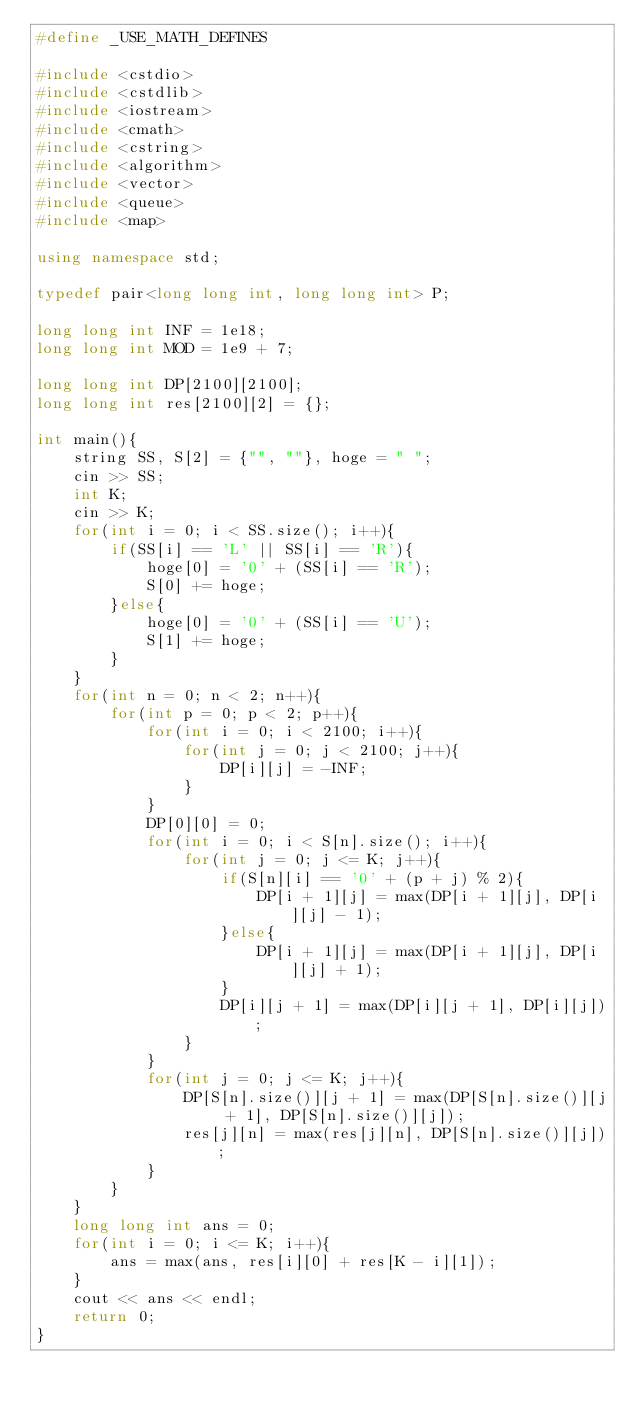Convert code to text. <code><loc_0><loc_0><loc_500><loc_500><_C++_>#define _USE_MATH_DEFINES

#include <cstdio>
#include <cstdlib>
#include <iostream>
#include <cmath>
#include <cstring>
#include <algorithm>
#include <vector>
#include <queue>
#include <map>

using namespace std;

typedef pair<long long int, long long int> P;

long long int INF = 1e18;
long long int MOD = 1e9 + 7;

long long int DP[2100][2100];
long long int res[2100][2] = {};

int main(){
    string SS, S[2] = {"", ""}, hoge = " ";
    cin >> SS;
    int K;
    cin >> K;
    for(int i = 0; i < SS.size(); i++){
        if(SS[i] == 'L' || SS[i] == 'R'){
            hoge[0] = '0' + (SS[i] == 'R');
            S[0] += hoge;
        }else{
            hoge[0] = '0' + (SS[i] == 'U');
            S[1] += hoge;
        }
    }
    for(int n = 0; n < 2; n++){
        for(int p = 0; p < 2; p++){
            for(int i = 0; i < 2100; i++){
                for(int j = 0; j < 2100; j++){
                    DP[i][j] = -INF;
                }
            }
            DP[0][0] = 0;
            for(int i = 0; i < S[n].size(); i++){
                for(int j = 0; j <= K; j++){
                    if(S[n][i] == '0' + (p + j) % 2){
                        DP[i + 1][j] = max(DP[i + 1][j], DP[i][j] - 1);
                    }else{
                        DP[i + 1][j] = max(DP[i + 1][j], DP[i][j] + 1);
                    }
                    DP[i][j + 1] = max(DP[i][j + 1], DP[i][j]);
                }
            }
            for(int j = 0; j <= K; j++){
                DP[S[n].size()][j + 1] = max(DP[S[n].size()][j + 1], DP[S[n].size()][j]);
                res[j][n] = max(res[j][n], DP[S[n].size()][j]);
            }
        }
    }
    long long int ans = 0;
    for(int i = 0; i <= K; i++){
        ans = max(ans, res[i][0] + res[K - i][1]);
    }
    cout << ans << endl;
    return 0;
}
</code> 